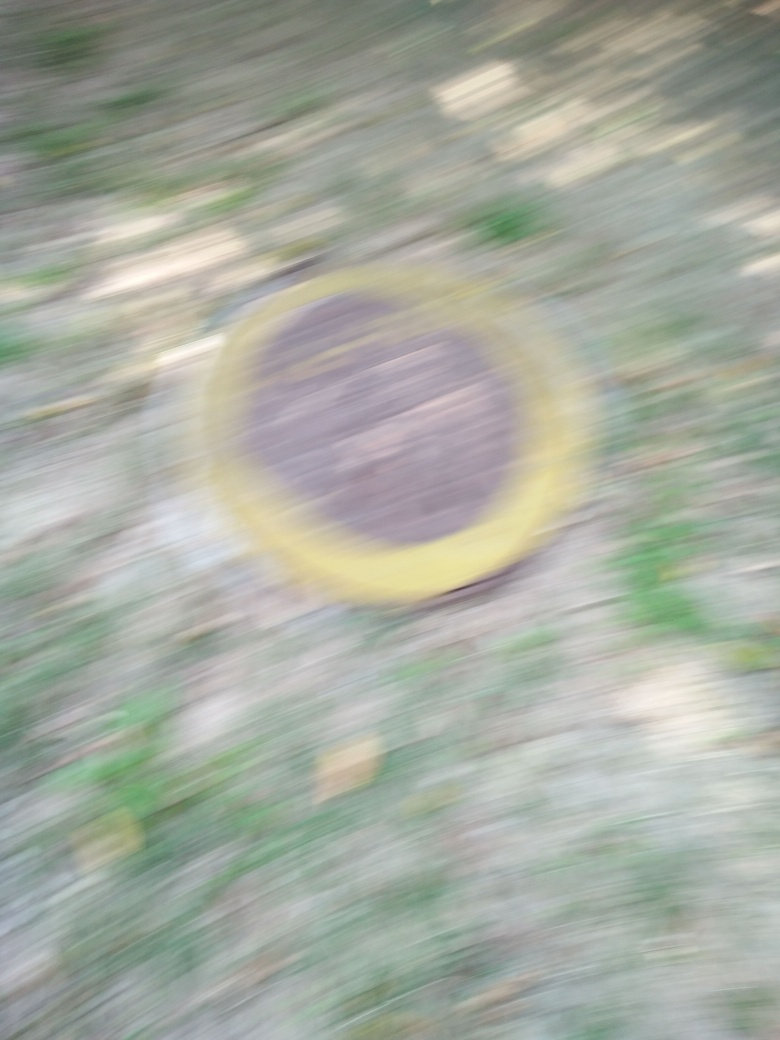How does the motion blur affect the composition of the photo? The motion blur transforms the photo's composition by softening lines and blending colors, creating a sense of movement and fluidity. It shifts the focus away from the sharpness of details towards the overall impression and emotion conveyed by the blurred shapes and color contrasts. 